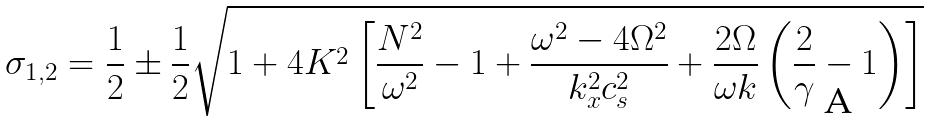Convert formula to latex. <formula><loc_0><loc_0><loc_500><loc_500>\sigma _ { 1 , 2 } = \frac { 1 } { 2 } \pm \frac { 1 } { 2 } \sqrt { 1 + 4 K ^ { 2 } \left [ \frac { N ^ { 2 } } { \omega ^ { 2 } } - 1 + \frac { \omega ^ { 2 } - 4 \Omega ^ { 2 } } { k _ { x } ^ { 2 } c _ { s } ^ { 2 } } + \frac { 2 \Omega } { \omega k } \left ( \frac { 2 } { \gamma } - 1 \right ) \right ] }</formula> 